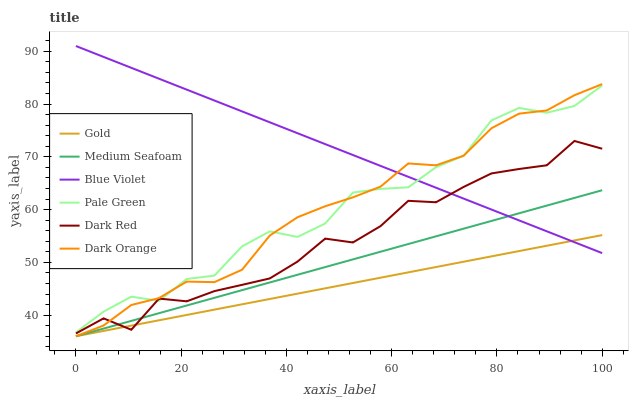Does Gold have the minimum area under the curve?
Answer yes or no. Yes. Does Blue Violet have the maximum area under the curve?
Answer yes or no. Yes. Does Dark Red have the minimum area under the curve?
Answer yes or no. No. Does Dark Red have the maximum area under the curve?
Answer yes or no. No. Is Gold the smoothest?
Answer yes or no. Yes. Is Pale Green the roughest?
Answer yes or no. Yes. Is Dark Red the smoothest?
Answer yes or no. No. Is Dark Red the roughest?
Answer yes or no. No. Does Dark Orange have the lowest value?
Answer yes or no. Yes. Does Dark Red have the lowest value?
Answer yes or no. No. Does Blue Violet have the highest value?
Answer yes or no. Yes. Does Dark Red have the highest value?
Answer yes or no. No. Is Medium Seafoam less than Pale Green?
Answer yes or no. Yes. Is Pale Green greater than Medium Seafoam?
Answer yes or no. Yes. Does Medium Seafoam intersect Gold?
Answer yes or no. Yes. Is Medium Seafoam less than Gold?
Answer yes or no. No. Is Medium Seafoam greater than Gold?
Answer yes or no. No. Does Medium Seafoam intersect Pale Green?
Answer yes or no. No. 